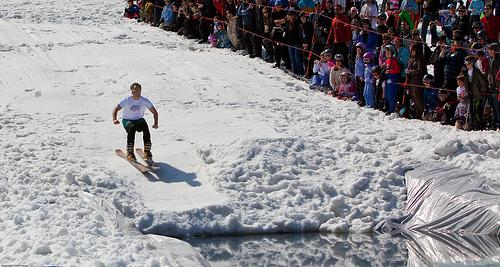Question: what is he doing?
Choices:
A. Swimming.
B. Hiking.
C. Climbing.
D. Skiing.
Answer with the letter. Answer: D Question: what are the fans doing?
Choices:
A. Cheering.
B. Screaming.
C. Watching.
D. Voting.
Answer with the letter. Answer: C 